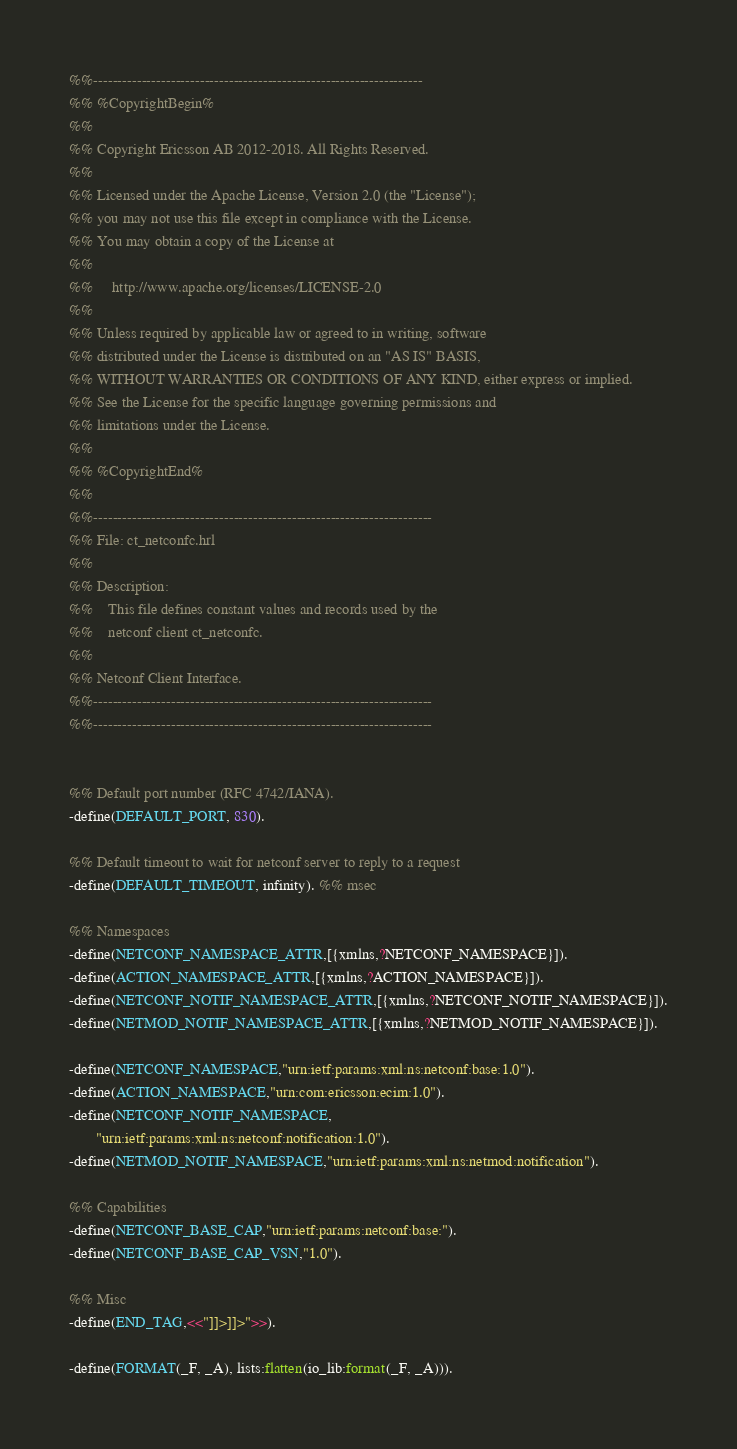<code> <loc_0><loc_0><loc_500><loc_500><_Erlang_>%%--------------------------------------------------------------------
%% %CopyrightBegin%
%%
%% Copyright Ericsson AB 2012-2018. All Rights Reserved.
%%
%% Licensed under the Apache License, Version 2.0 (the "License");
%% you may not use this file except in compliance with the License.
%% You may obtain a copy of the License at
%%
%%     http://www.apache.org/licenses/LICENSE-2.0
%%
%% Unless required by applicable law or agreed to in writing, software
%% distributed under the License is distributed on an "AS IS" BASIS,
%% WITHOUT WARRANTIES OR CONDITIONS OF ANY KIND, either express or implied.
%% See the License for the specific language governing permissions and
%% limitations under the License.
%%
%% %CopyrightEnd%
%%
%%----------------------------------------------------------------------
%% File: ct_netconfc.hrl
%%
%% Description:
%%    This file defines constant values and records used by the
%%    netconf client ct_netconfc.
%%
%% Netconf Client Interface.
%%----------------------------------------------------------------------
%%----------------------------------------------------------------------


%% Default port number (RFC 4742/IANA).
-define(DEFAULT_PORT, 830).

%% Default timeout to wait for netconf server to reply to a request
-define(DEFAULT_TIMEOUT, infinity). %% msec

%% Namespaces
-define(NETCONF_NAMESPACE_ATTR,[{xmlns,?NETCONF_NAMESPACE}]).
-define(ACTION_NAMESPACE_ATTR,[{xmlns,?ACTION_NAMESPACE}]).
-define(NETCONF_NOTIF_NAMESPACE_ATTR,[{xmlns,?NETCONF_NOTIF_NAMESPACE}]).
-define(NETMOD_NOTIF_NAMESPACE_ATTR,[{xmlns,?NETMOD_NOTIF_NAMESPACE}]).

-define(NETCONF_NAMESPACE,"urn:ietf:params:xml:ns:netconf:base:1.0").
-define(ACTION_NAMESPACE,"urn:com:ericsson:ecim:1.0").
-define(NETCONF_NOTIF_NAMESPACE,
       "urn:ietf:params:xml:ns:netconf:notification:1.0").
-define(NETMOD_NOTIF_NAMESPACE,"urn:ietf:params:xml:ns:netmod:notification").

%% Capabilities
-define(NETCONF_BASE_CAP,"urn:ietf:params:netconf:base:").
-define(NETCONF_BASE_CAP_VSN,"1.0").

%% Misc
-define(END_TAG,<<"]]>]]>">>).

-define(FORMAT(_F, _A), lists:flatten(io_lib:format(_F, _A))).
</code> 